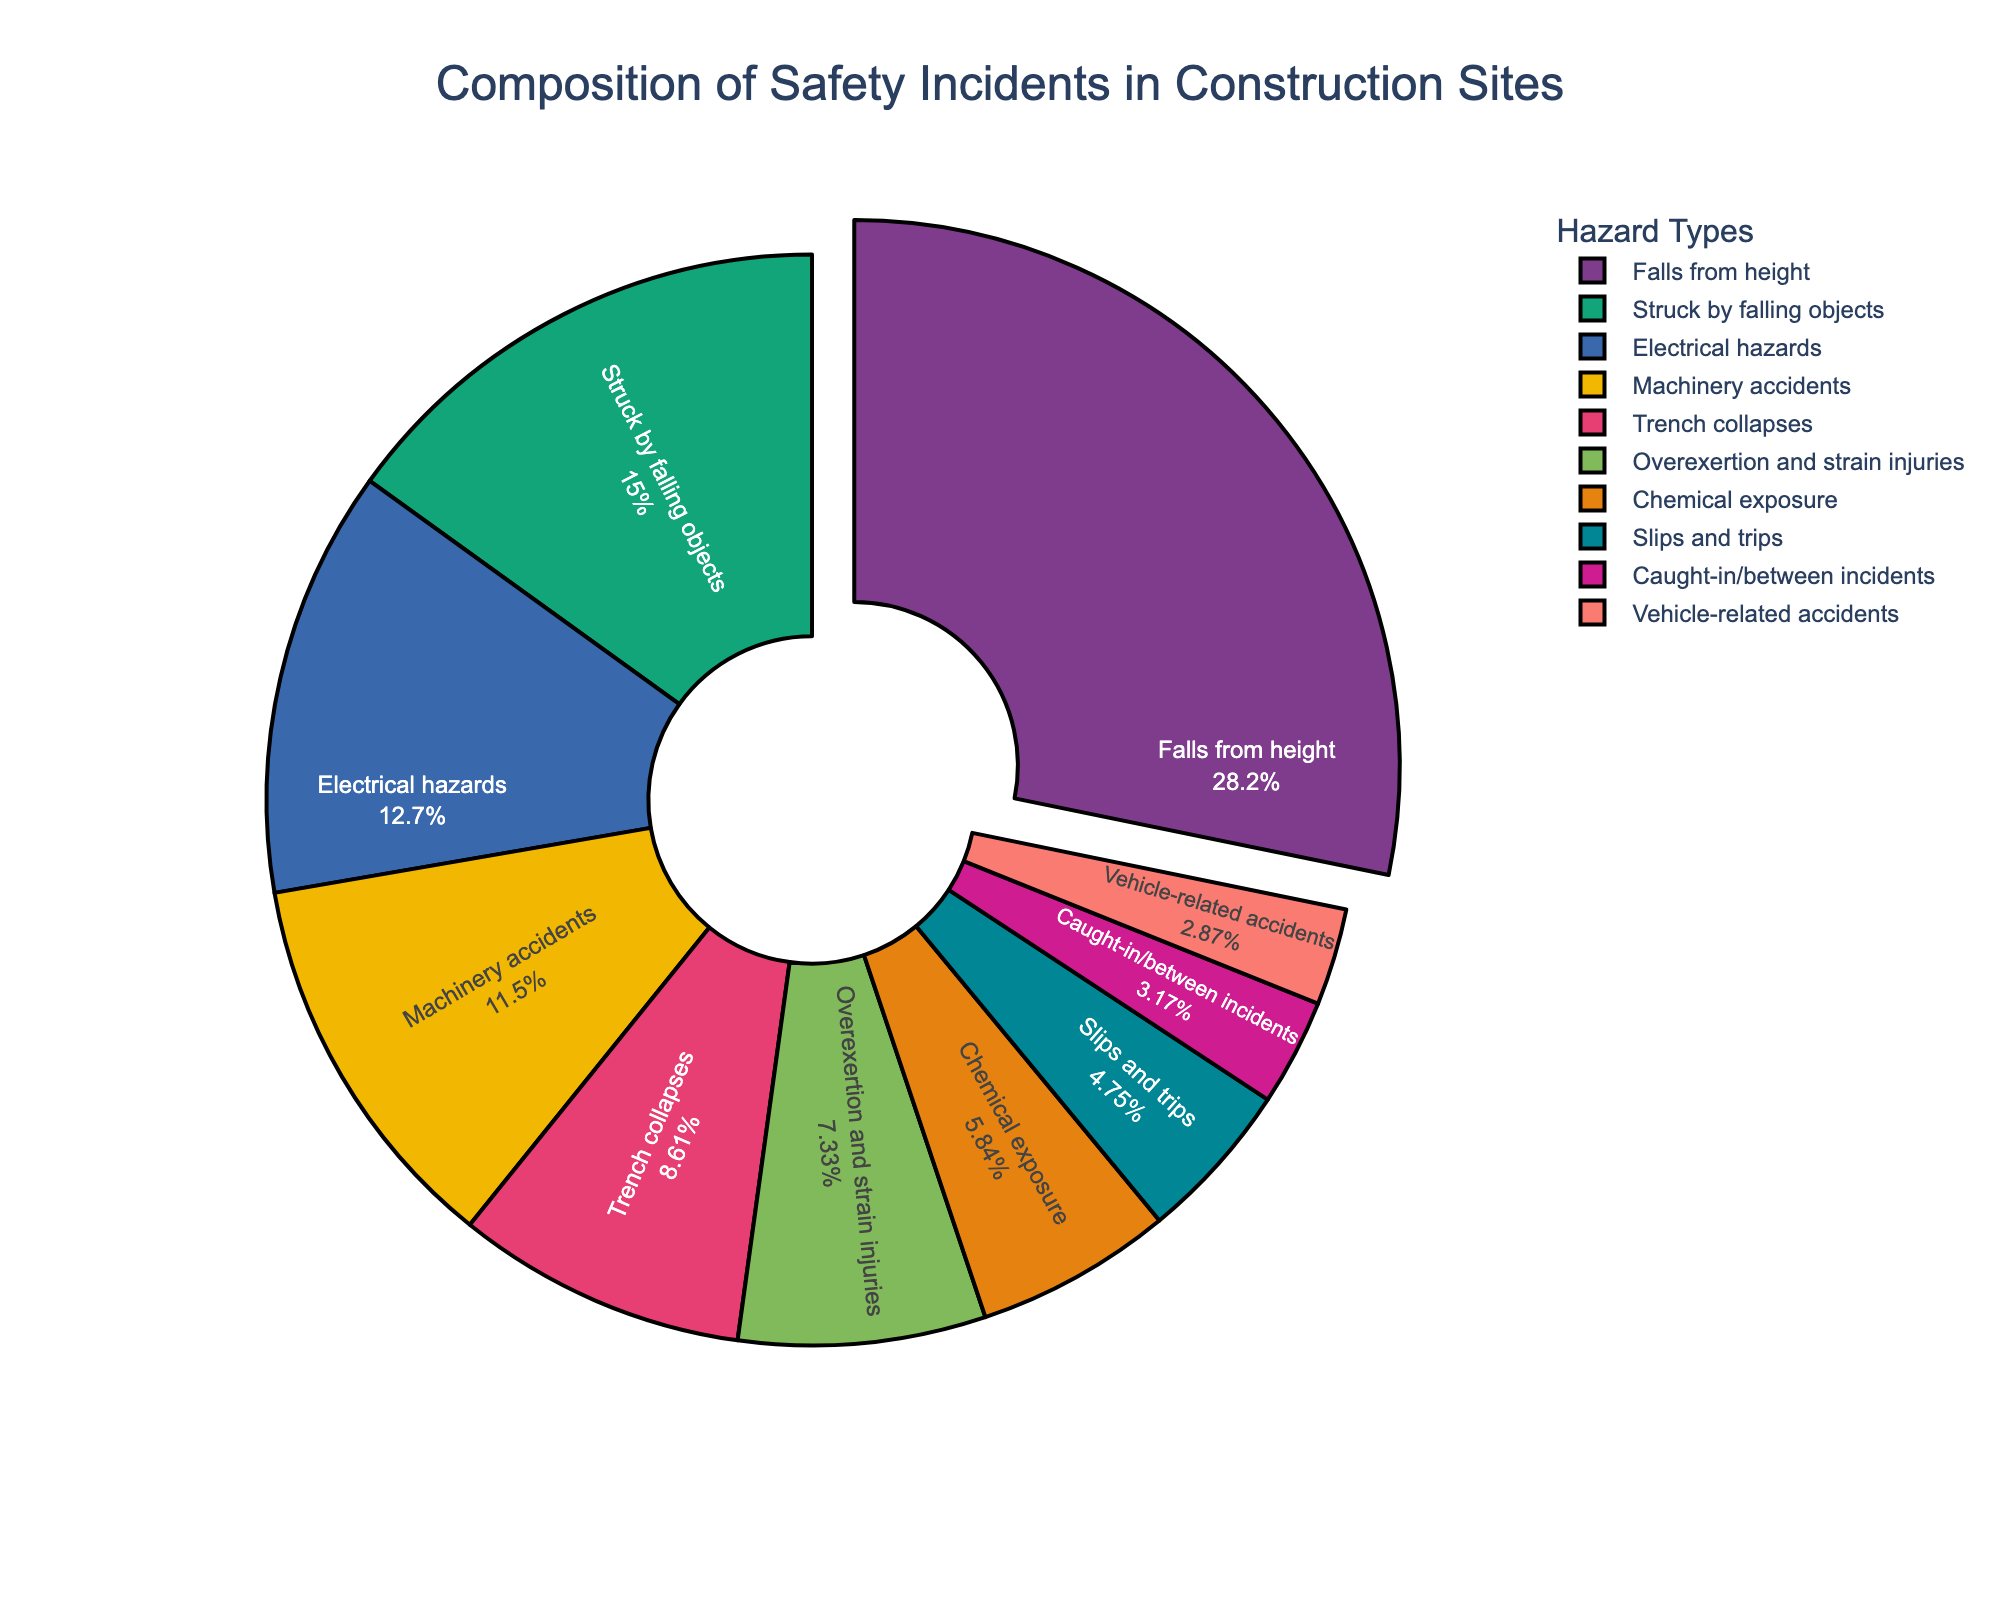What's the percentage of incidents caused by falls from height and trench collapses combined? First, find the percentage of falls from height (28.5%) and trench collapses (8.7%) from the chart. Then add these two percentages together. 28.5 + 8.7 = 37.2
Answer: 37.2 Which hazard type has the smallest percentage of safety incidents, and what is the percentage? Look for the smallest segment in the pie chart, which represents the hazard type with the smallest percentage. The smallest segment is vehicle-related accidents, with a percentage of 2.9.
Answer: Vehicle-related accidents, 2.9 How much higher is the percentage of incidents caused by falls from height compared to electrical hazards? Find the percentage of falls from height (28.5%) and electrical hazards (12.8%) from the chart. Subtract the percentage of electrical hazards from that of falls from height. 28.5 - 12.8 = 15.7
Answer: 15.7 What is the combined percentage of incidents caused by electrical hazards, machinery accidents, and chemical exposure? Find the percentages for electrical hazards (12.8%), machinery accidents (11.6%), and chemical exposure (5.9%) from the chart. Add these percentages together. 12.8 + 11.6 + 5.9 = 30.3
Answer: 30.3 What is the second most common type of hazard and its percentage? The first most common hazard type is falls from height with the highest percentage (28.5%). The second largest segment in the pie chart is struck by falling objects with a percentage of 15.2%.
Answer: Struck by falling objects, 15.2 Which hazard type has a percentage less than 10% but more than 5%? Identify the hazard types with percentages between 5% and 10%. Overexertion and strain injuries (7.4%), trench collapses (8.7%), and chemical exposure (5.9%) fit this criterion.
Answer: Overexertion and strain injuries, trench collapses, chemical exposure Which hazard types together make up roughly half of the total safety incidents? Identify and add percentages until you reach approximately 50%. Falls from height (28.5%), struck by falling objects (15.2%), and electrical hazards (12.8%) together make up 28.5 + 15.2 + 12.8 = 56.5. This is slightly above 50%, so we need to exclude the last one added. Now try falls from height (28.5%) and struck by falling objects (15.2%), which together make 28.5 + 15.2 = 43.7, and then add machinery accidents (11.6%) to get 43.7 + 11.6 = 55.3.
Answer: Falls from height, struck by falling objects, machinery accidents What colors represent electrical hazards and slips and trips in the pie chart? Look at the distinct colors used in the pie chart for the segments labeled "Electrical hazards" and "Slips and trips".
Answer: The answer depends on the visual inspection of the plot 